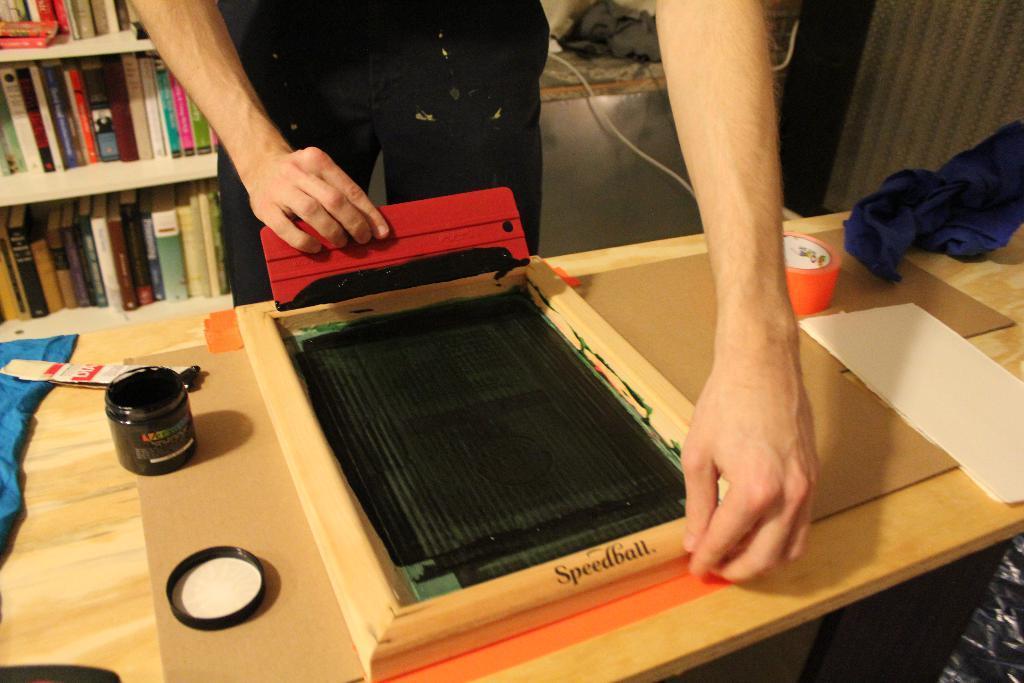In one or two sentences, can you explain what this image depicts? In the image we can see there is a person standing and there is paper kept on the table. There is cloth and ink pot kept on the table. Behind there are books kept in the shelves. 